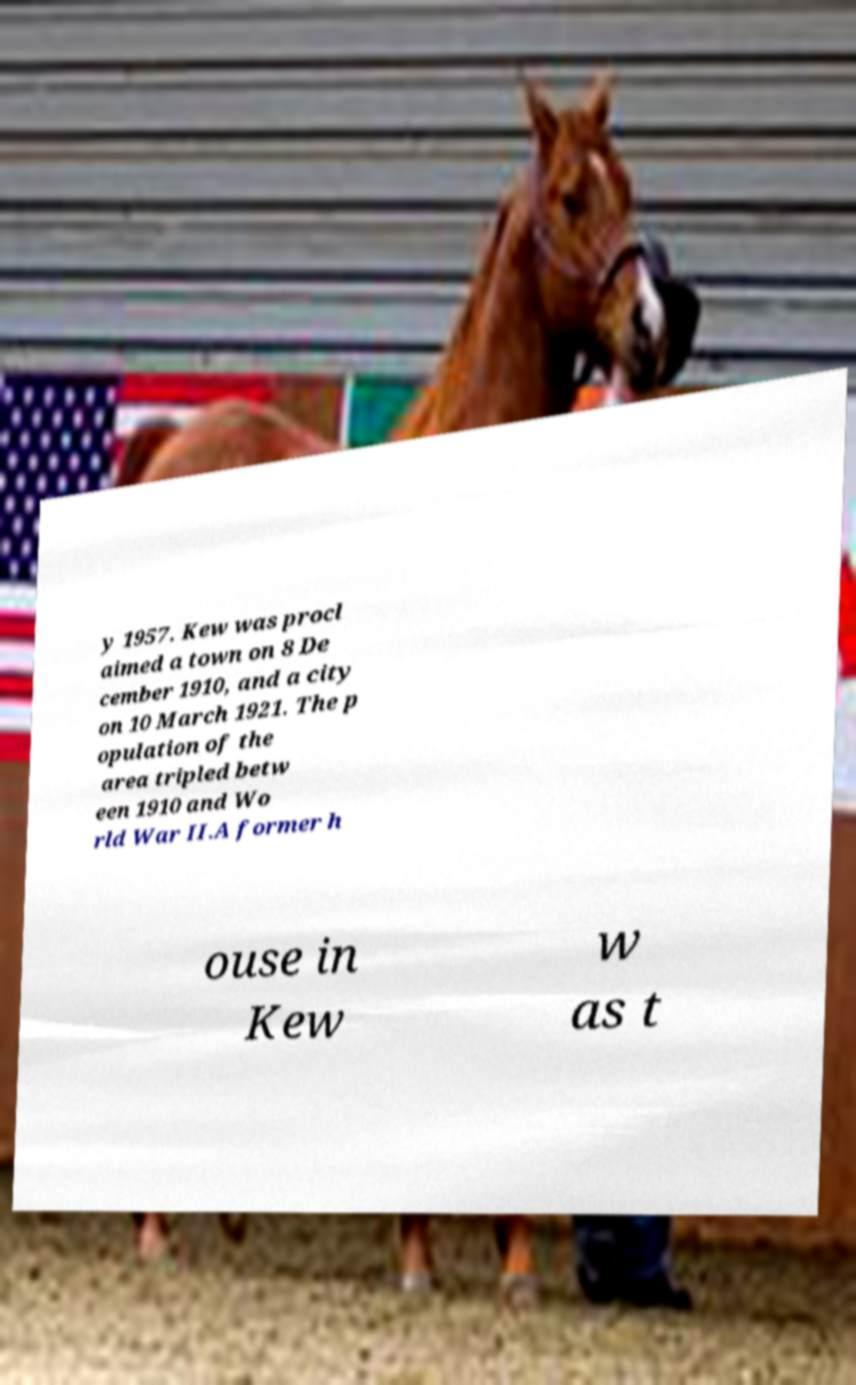Could you extract and type out the text from this image? y 1957. Kew was procl aimed a town on 8 De cember 1910, and a city on 10 March 1921. The p opulation of the area tripled betw een 1910 and Wo rld War II.A former h ouse in Kew w as t 